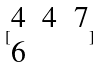Convert formula to latex. <formula><loc_0><loc_0><loc_500><loc_500>[ \begin{matrix} 4 & 4 & 7 \\ 6 \end{matrix} ]</formula> 